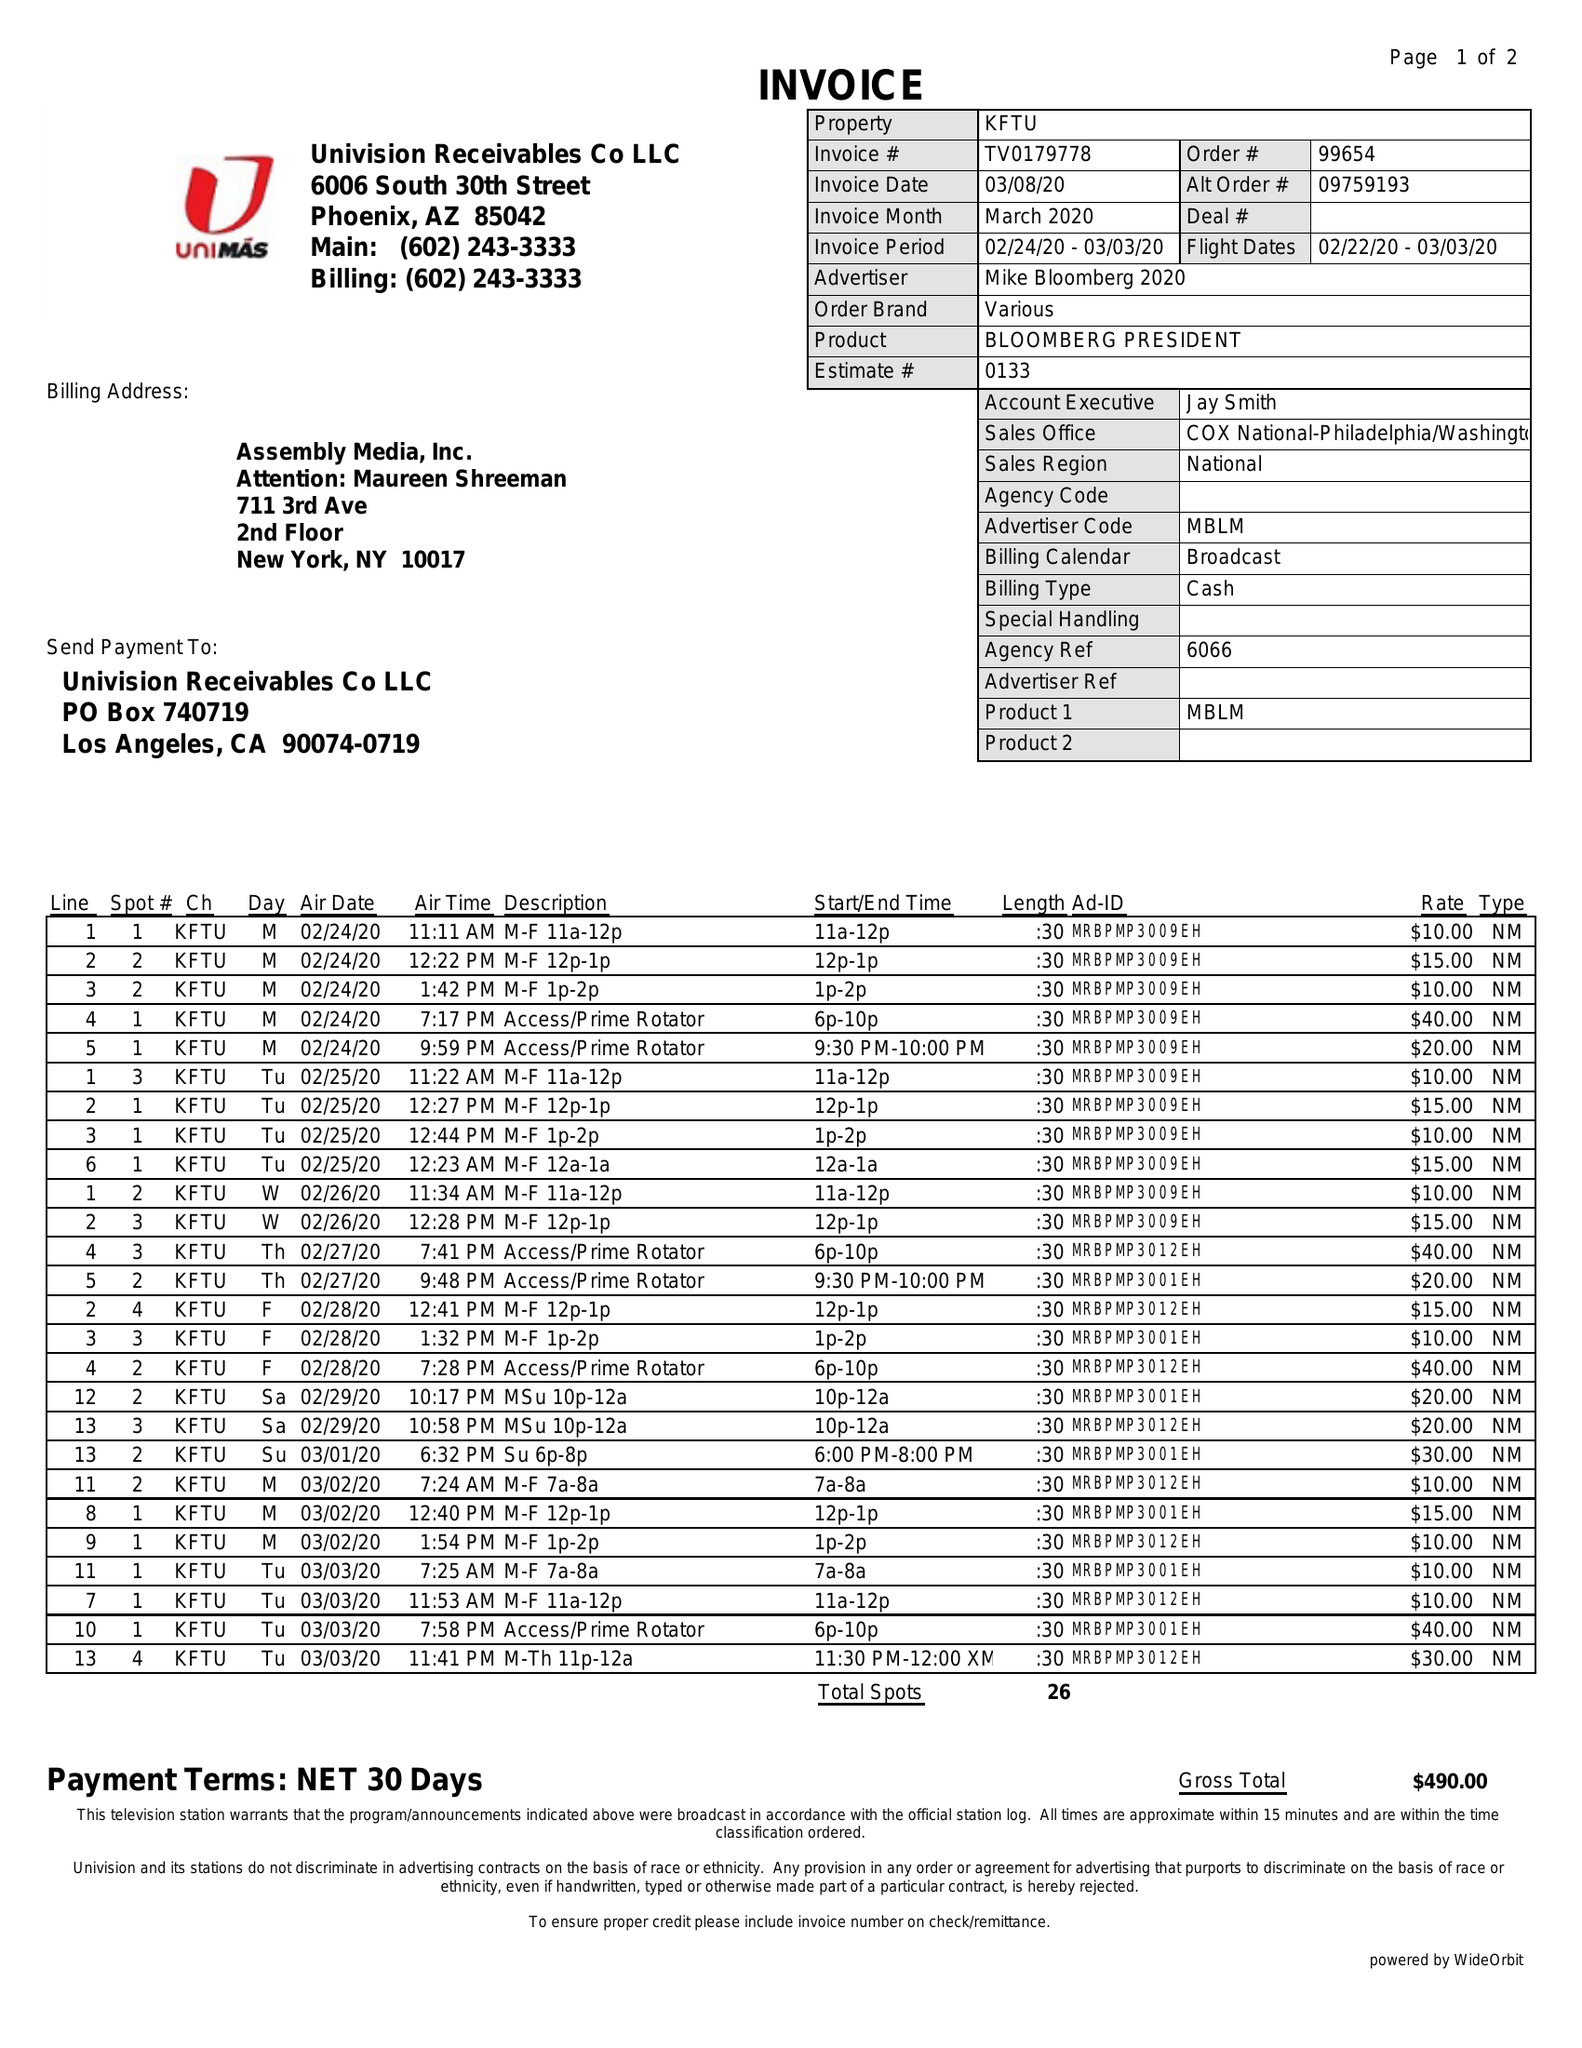What is the value for the flight_to?
Answer the question using a single word or phrase. 03/03/20 